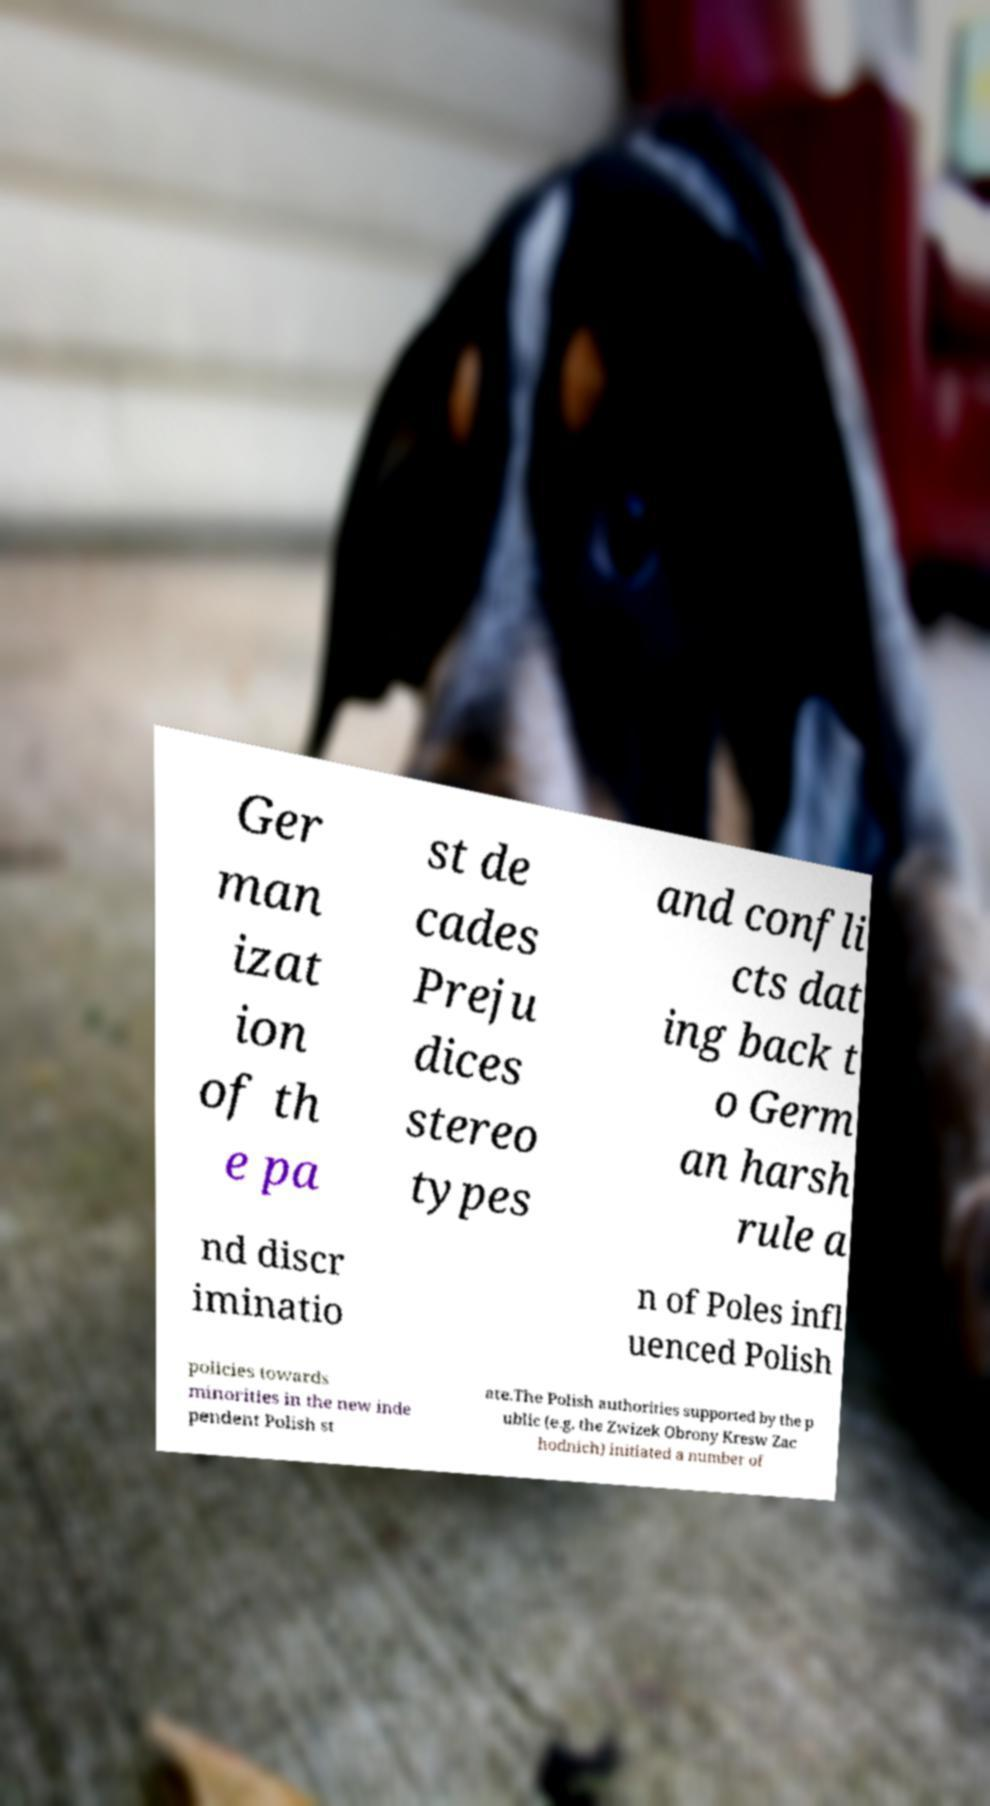Could you assist in decoding the text presented in this image and type it out clearly? Ger man izat ion of th e pa st de cades Preju dices stereo types and confli cts dat ing back t o Germ an harsh rule a nd discr iminatio n of Poles infl uenced Polish policies towards minorities in the new inde pendent Polish st ate.The Polish authorities supported by the p ublic (e.g. the Zwizek Obrony Kresw Zac hodnich) initiated a number of 